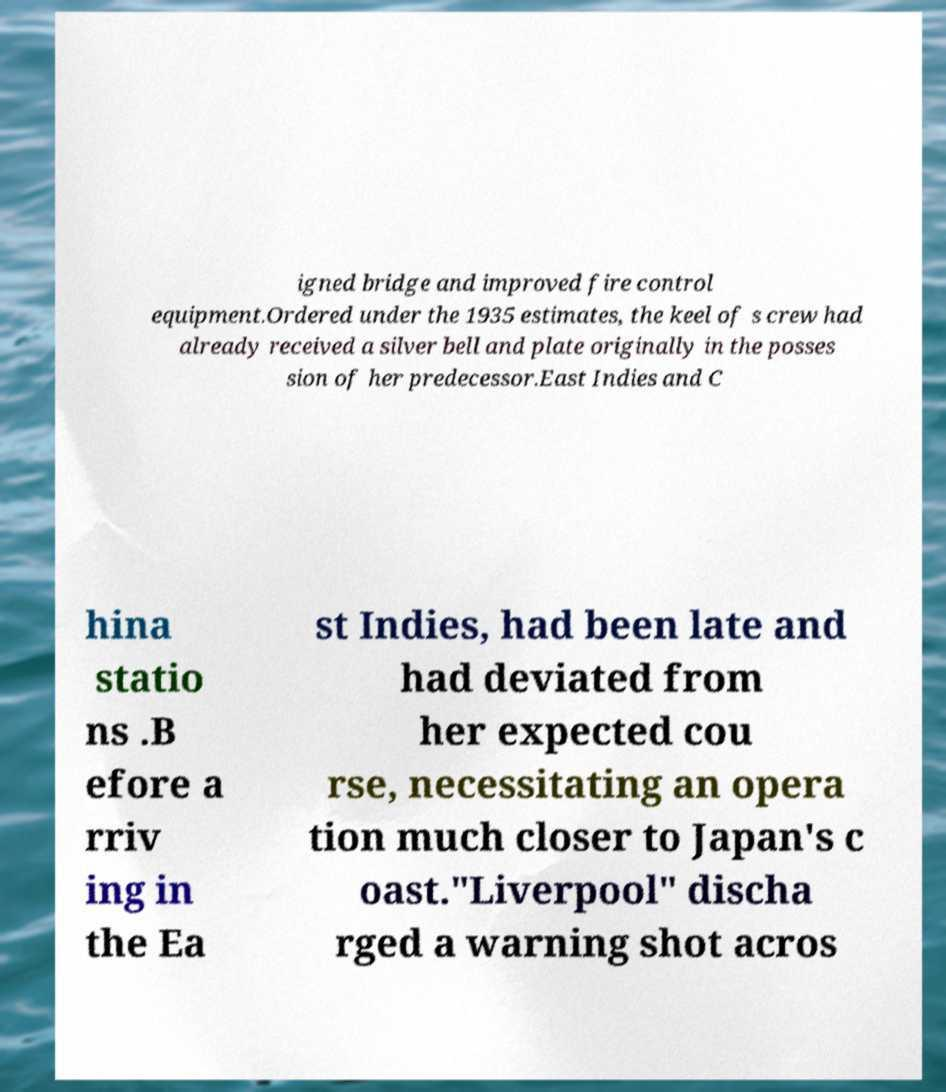There's text embedded in this image that I need extracted. Can you transcribe it verbatim? igned bridge and improved fire control equipment.Ordered under the 1935 estimates, the keel of s crew had already received a silver bell and plate originally in the posses sion of her predecessor.East Indies and C hina statio ns .B efore a rriv ing in the Ea st Indies, had been late and had deviated from her expected cou rse, necessitating an opera tion much closer to Japan's c oast."Liverpool" discha rged a warning shot acros 